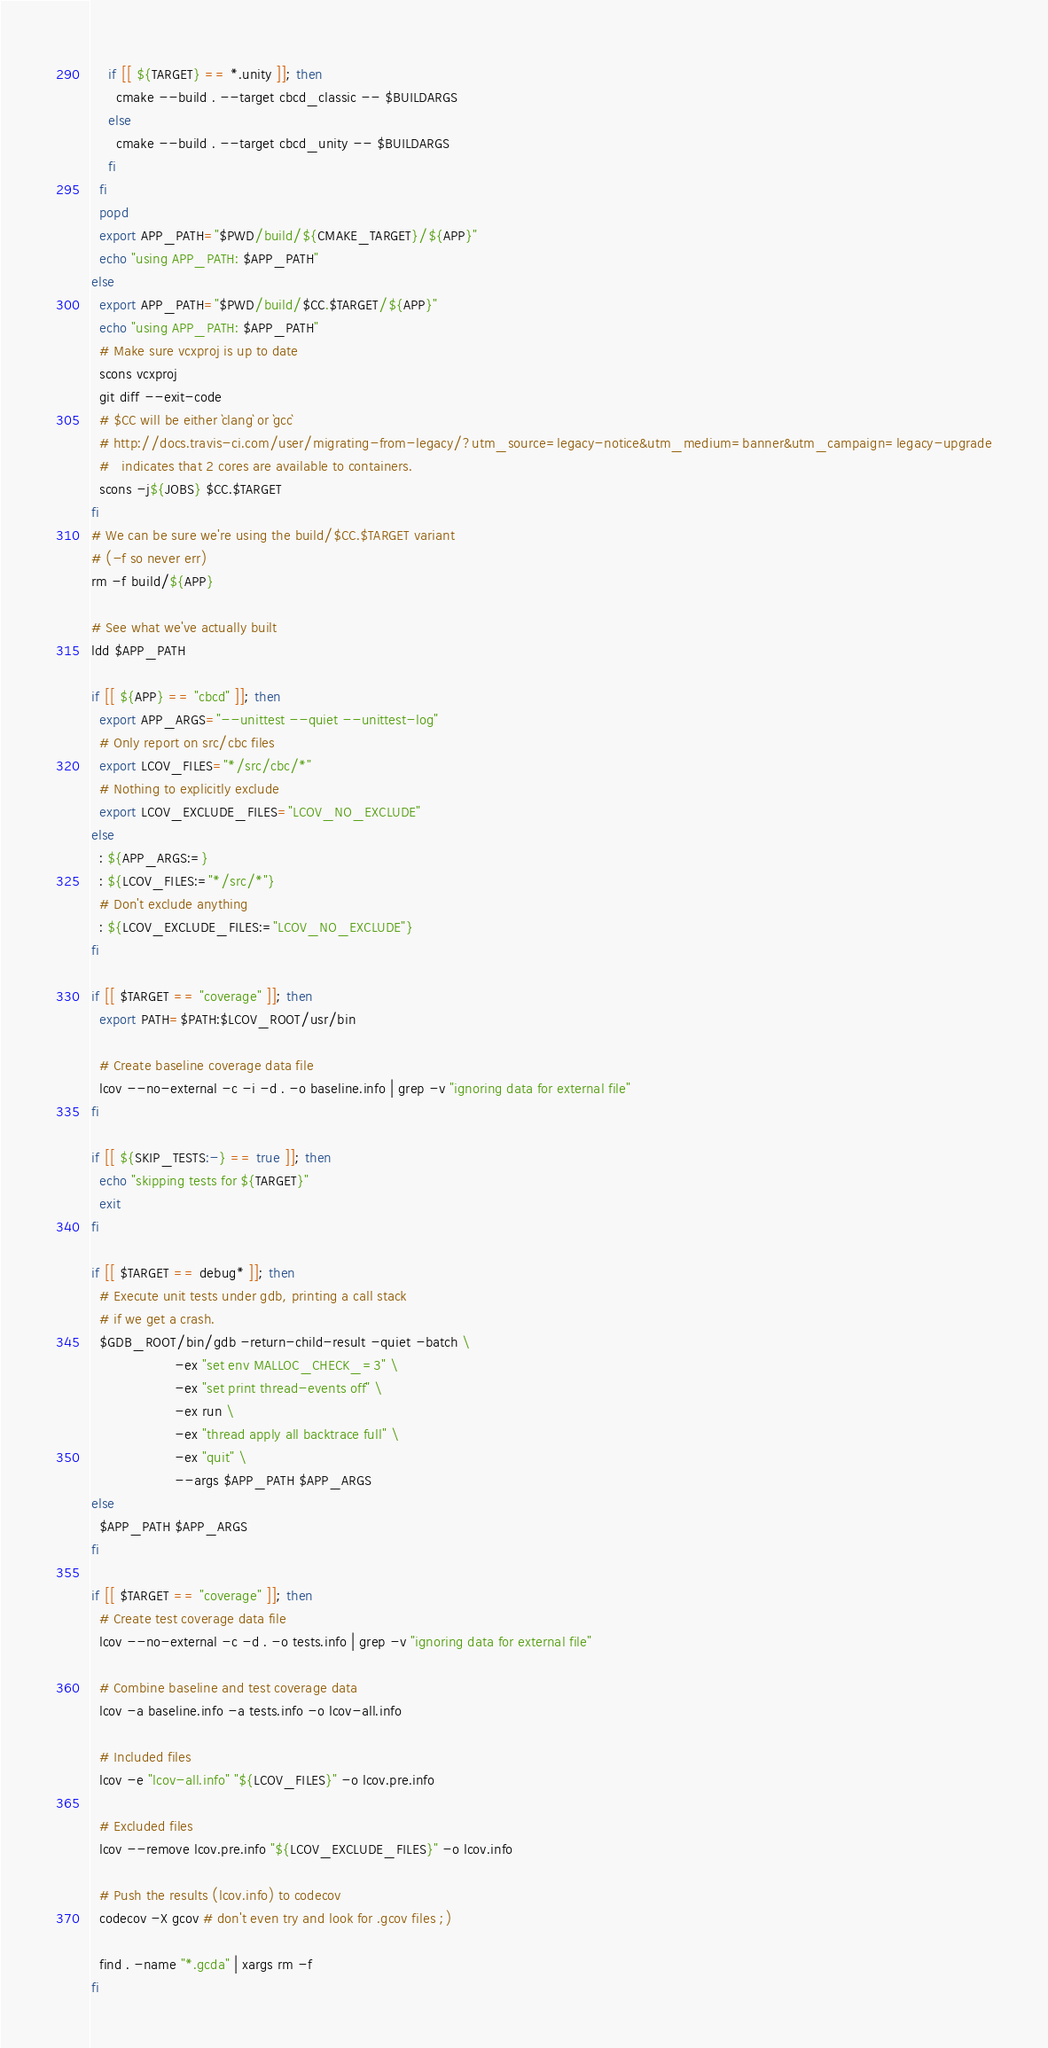<code> <loc_0><loc_0><loc_500><loc_500><_Bash_>    if [[ ${TARGET} == *.unity ]]; then
      cmake --build . --target cbcd_classic -- $BUILDARGS
    else
      cmake --build . --target cbcd_unity -- $BUILDARGS
    fi
  fi
  popd
  export APP_PATH="$PWD/build/${CMAKE_TARGET}/${APP}"
  echo "using APP_PATH: $APP_PATH"
else
  export APP_PATH="$PWD/build/$CC.$TARGET/${APP}"
  echo "using APP_PATH: $APP_PATH"
  # Make sure vcxproj is up to date
  scons vcxproj
  git diff --exit-code
  # $CC will be either `clang` or `gcc`
  # http://docs.travis-ci.com/user/migrating-from-legacy/?utm_source=legacy-notice&utm_medium=banner&utm_campaign=legacy-upgrade
  #   indicates that 2 cores are available to containers.
  scons -j${JOBS} $CC.$TARGET
fi
# We can be sure we're using the build/$CC.$TARGET variant
# (-f so never err)
rm -f build/${APP}

# See what we've actually built
ldd $APP_PATH

if [[ ${APP} == "cbcd" ]]; then
  export APP_ARGS="--unittest --quiet --unittest-log"
  # Only report on src/cbc files
  export LCOV_FILES="*/src/cbc/*"
  # Nothing to explicitly exclude
  export LCOV_EXCLUDE_FILES="LCOV_NO_EXCLUDE"
else
  : ${APP_ARGS:=}
  : ${LCOV_FILES:="*/src/*"}
  # Don't exclude anything
  : ${LCOV_EXCLUDE_FILES:="LCOV_NO_EXCLUDE"}
fi

if [[ $TARGET == "coverage" ]]; then
  export PATH=$PATH:$LCOV_ROOT/usr/bin

  # Create baseline coverage data file
  lcov --no-external -c -i -d . -o baseline.info | grep -v "ignoring data for external file"
fi

if [[ ${SKIP_TESTS:-} == true ]]; then
  echo "skipping tests for ${TARGET}"
  exit
fi

if [[ $TARGET == debug* ]]; then
  # Execute unit tests under gdb, printing a call stack
  # if we get a crash.
  $GDB_ROOT/bin/gdb -return-child-result -quiet -batch \
                    -ex "set env MALLOC_CHECK_=3" \
                    -ex "set print thread-events off" \
                    -ex run \
                    -ex "thread apply all backtrace full" \
                    -ex "quit" \
                    --args $APP_PATH $APP_ARGS
else
  $APP_PATH $APP_ARGS
fi

if [[ $TARGET == "coverage" ]]; then
  # Create test coverage data file
  lcov --no-external -c -d . -o tests.info | grep -v "ignoring data for external file"

  # Combine baseline and test coverage data
  lcov -a baseline.info -a tests.info -o lcov-all.info

  # Included files
  lcov -e "lcov-all.info" "${LCOV_FILES}" -o lcov.pre.info

  # Excluded files
  lcov --remove lcov.pre.info "${LCOV_EXCLUDE_FILES}" -o lcov.info

  # Push the results (lcov.info) to codecov
  codecov -X gcov # don't even try and look for .gcov files ;)

  find . -name "*.gcda" | xargs rm -f
fi


</code> 